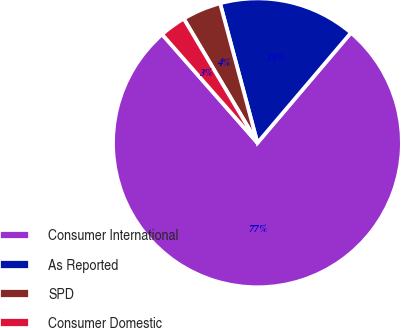Convert chart. <chart><loc_0><loc_0><loc_500><loc_500><pie_chart><fcel>Consumer International<fcel>As Reported<fcel>SPD<fcel>Consumer Domestic<nl><fcel>77.32%<fcel>15.37%<fcel>4.36%<fcel>2.95%<nl></chart> 